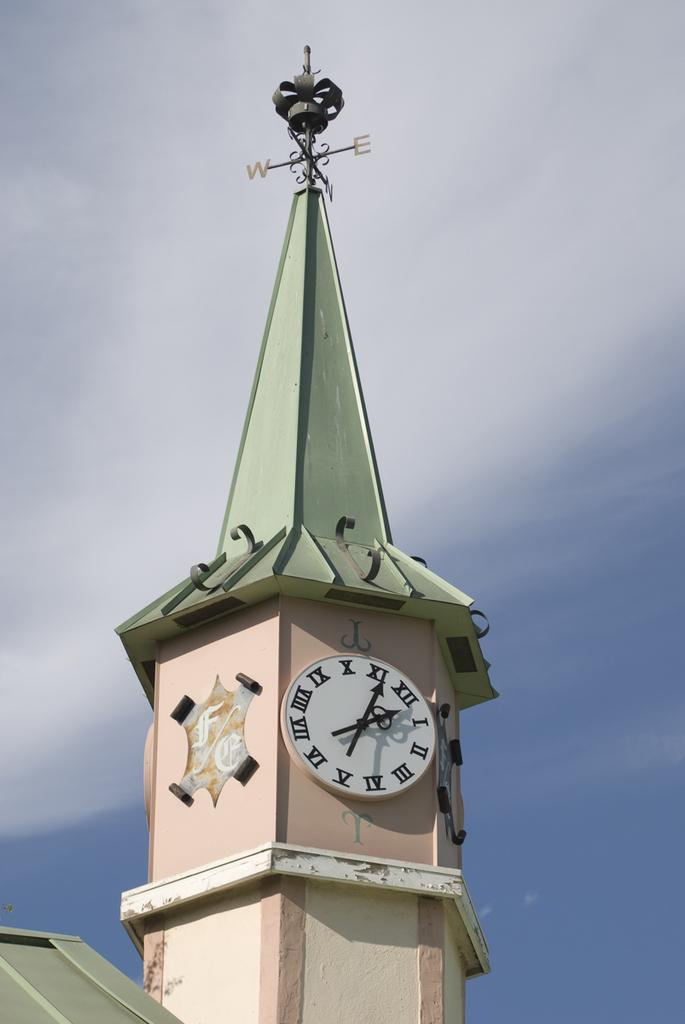<image>
Render a clear and concise summary of the photo. A clock on top of a pink steeple points to the numbers 1 and 11 